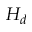<formula> <loc_0><loc_0><loc_500><loc_500>H _ { d }</formula> 